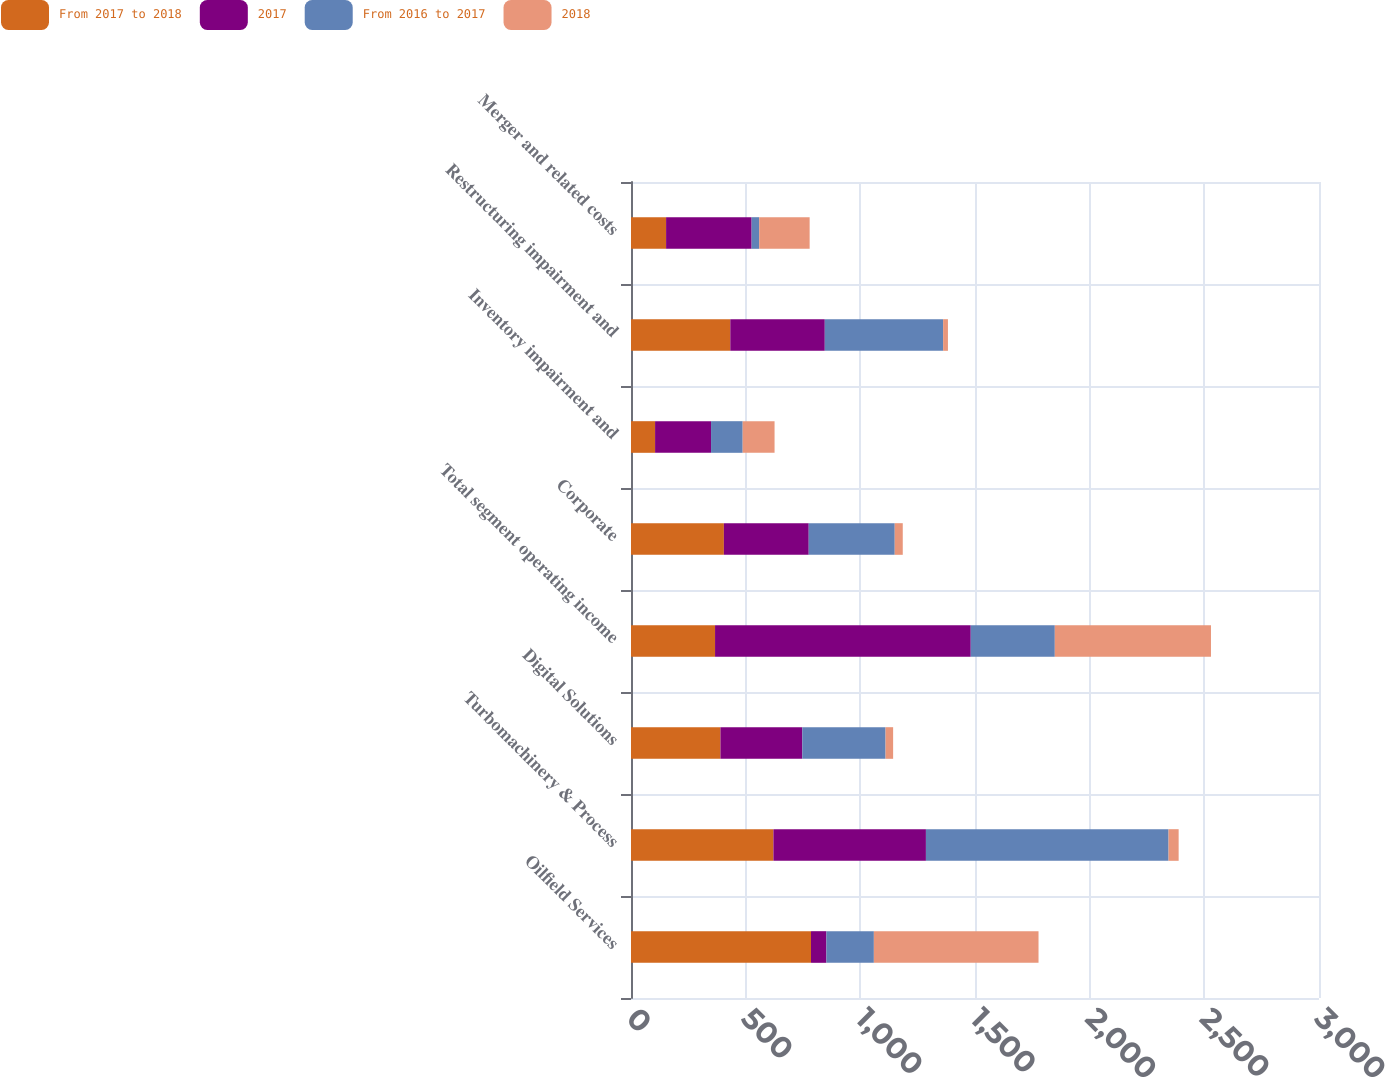Convert chart. <chart><loc_0><loc_0><loc_500><loc_500><stacked_bar_chart><ecel><fcel>Oilfield Services<fcel>Turbomachinery & Process<fcel>Digital Solutions<fcel>Total segment operating income<fcel>Corporate<fcel>Inventory impairment and<fcel>Restructuring impairment and<fcel>Merger and related costs<nl><fcel>From 2017 to 2018<fcel>785<fcel>621<fcel>390<fcel>366.5<fcel>405<fcel>105<fcel>433<fcel>153<nl><fcel>2017<fcel>67<fcel>665<fcel>357<fcel>1115<fcel>370<fcel>244<fcel>412<fcel>373<nl><fcel>From 2016 to 2017<fcel>207<fcel>1058<fcel>363<fcel>366.5<fcel>375<fcel>138<fcel>516<fcel>33<nl><fcel>2018<fcel>718<fcel>44<fcel>33<fcel>681<fcel>35<fcel>139<fcel>21<fcel>220<nl></chart> 